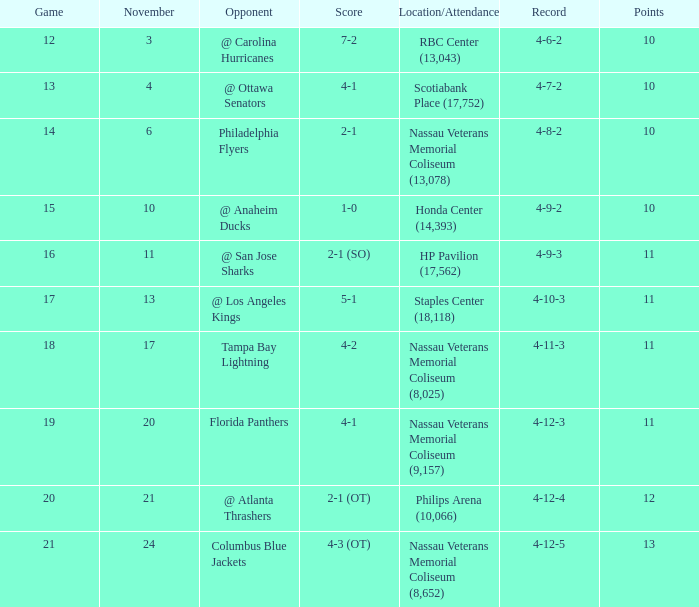What is the minimum requirement for entry if the score is 1-0? 15.0. 